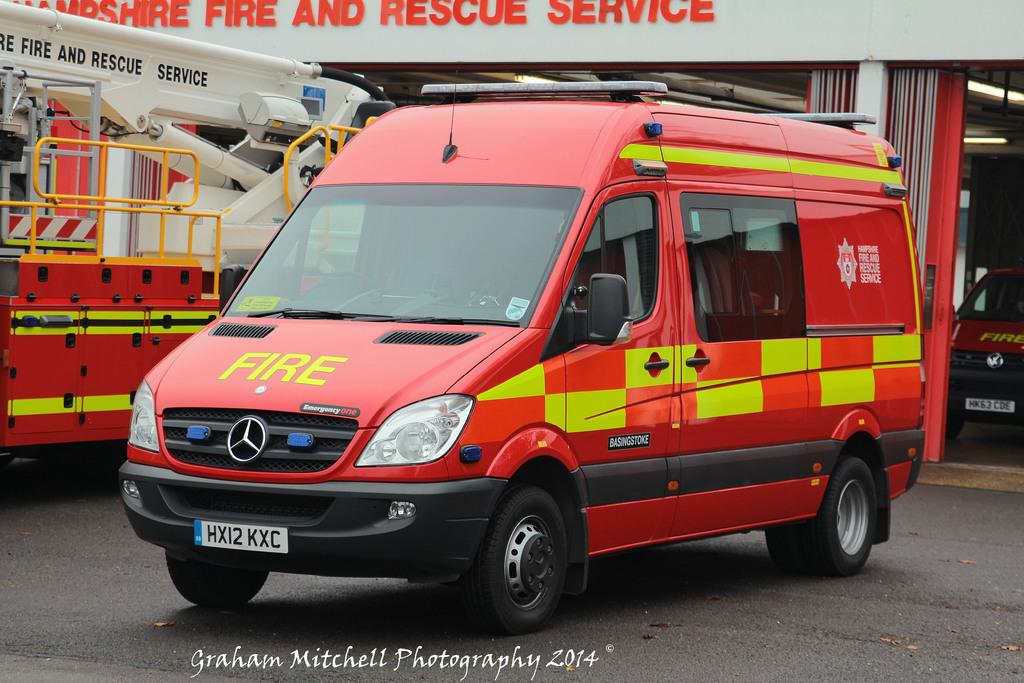What type of vehicles are present in the image? There are fire rescue vehicles in the image. What is located behind the fire rescue vehicles? There is a compartment behind the vehicles. What can be found inside the compartment? There is another vehicle inside the compartment. What type of clover is growing near the fire rescue vehicles in the image? There is no clover visible in the image; the focus is on the vehicles and the compartment. 